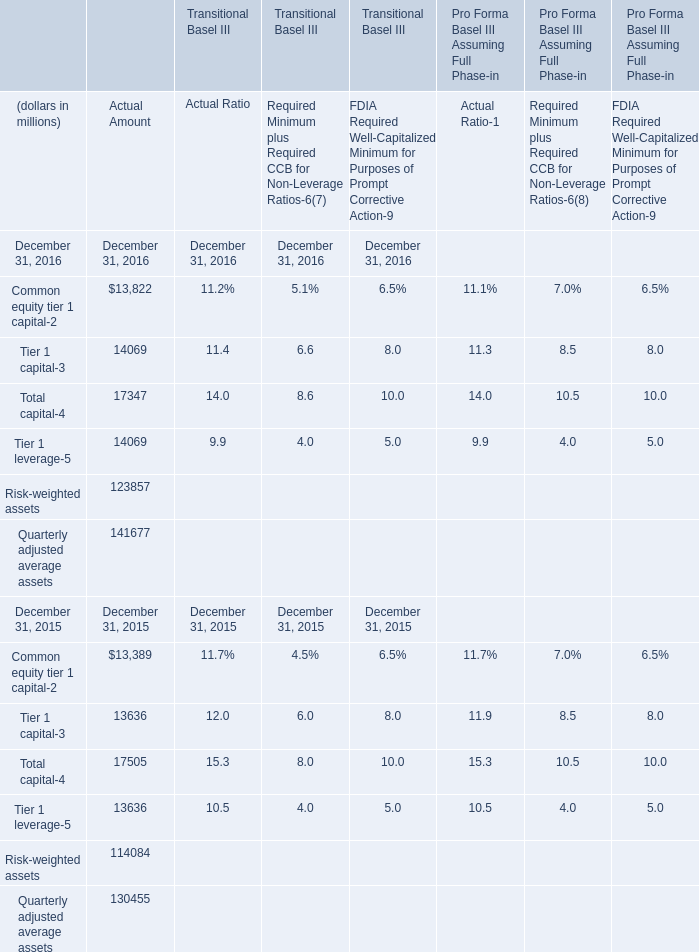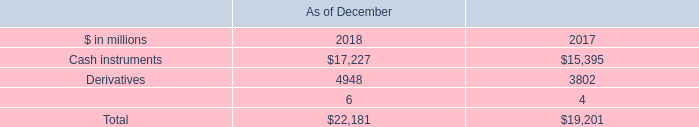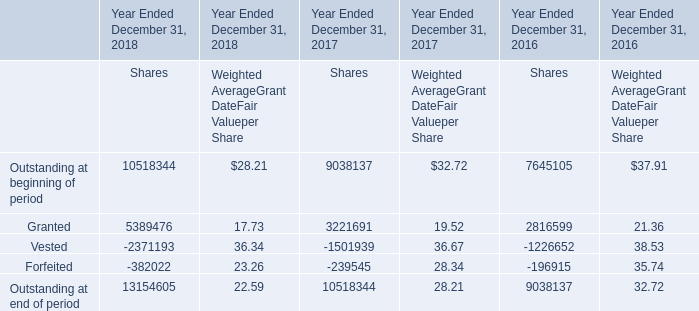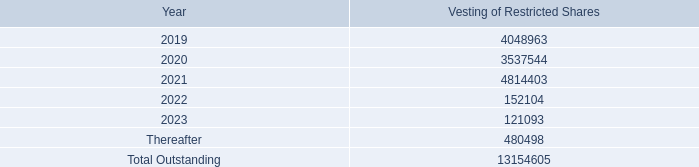What's the sum of Derivatives of As of December 2017, 2023 of Vesting of Restricted Shares 4,048,963 3,537,544 4,814,403, and Granted of Year Ended December 31, 2017 Shares ? 
Computations: ((3802.0 + 121093.0) + 3221691.0)
Answer: 3346586.0. 